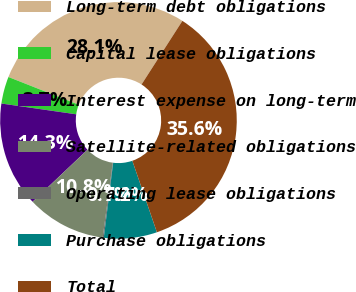<chart> <loc_0><loc_0><loc_500><loc_500><pie_chart><fcel>Long-term debt obligations<fcel>Capital lease obligations<fcel>Interest expense on long-term<fcel>Satellite-related obligations<fcel>Operating lease obligations<fcel>Purchase obligations<fcel>Total<nl><fcel>28.11%<fcel>3.7%<fcel>14.35%<fcel>10.8%<fcel>0.15%<fcel>7.25%<fcel>35.65%<nl></chart> 